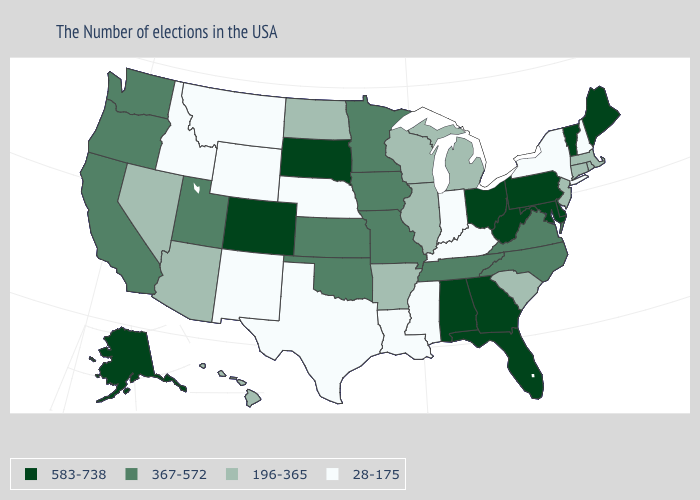Does the map have missing data?
Write a very short answer. No. Name the states that have a value in the range 196-365?
Short answer required. Massachusetts, Rhode Island, Connecticut, New Jersey, South Carolina, Michigan, Wisconsin, Illinois, Arkansas, North Dakota, Arizona, Nevada, Hawaii. What is the lowest value in states that border North Carolina?
Concise answer only. 196-365. How many symbols are there in the legend?
Quick response, please. 4. What is the highest value in the USA?
Answer briefly. 583-738. Name the states that have a value in the range 583-738?
Keep it brief. Maine, Vermont, Delaware, Maryland, Pennsylvania, West Virginia, Ohio, Florida, Georgia, Alabama, South Dakota, Colorado, Alaska. Among the states that border New Hampshire , does Massachusetts have the lowest value?
Write a very short answer. Yes. Does New Jersey have the lowest value in the Northeast?
Short answer required. No. What is the value of New Mexico?
Give a very brief answer. 28-175. Is the legend a continuous bar?
Short answer required. No. Name the states that have a value in the range 367-572?
Be succinct. Virginia, North Carolina, Tennessee, Missouri, Minnesota, Iowa, Kansas, Oklahoma, Utah, California, Washington, Oregon. Name the states that have a value in the range 196-365?
Write a very short answer. Massachusetts, Rhode Island, Connecticut, New Jersey, South Carolina, Michigan, Wisconsin, Illinois, Arkansas, North Dakota, Arizona, Nevada, Hawaii. Which states have the lowest value in the USA?
Keep it brief. New Hampshire, New York, Kentucky, Indiana, Mississippi, Louisiana, Nebraska, Texas, Wyoming, New Mexico, Montana, Idaho. What is the highest value in states that border Tennessee?
Write a very short answer. 583-738. Does the first symbol in the legend represent the smallest category?
Keep it brief. No. 